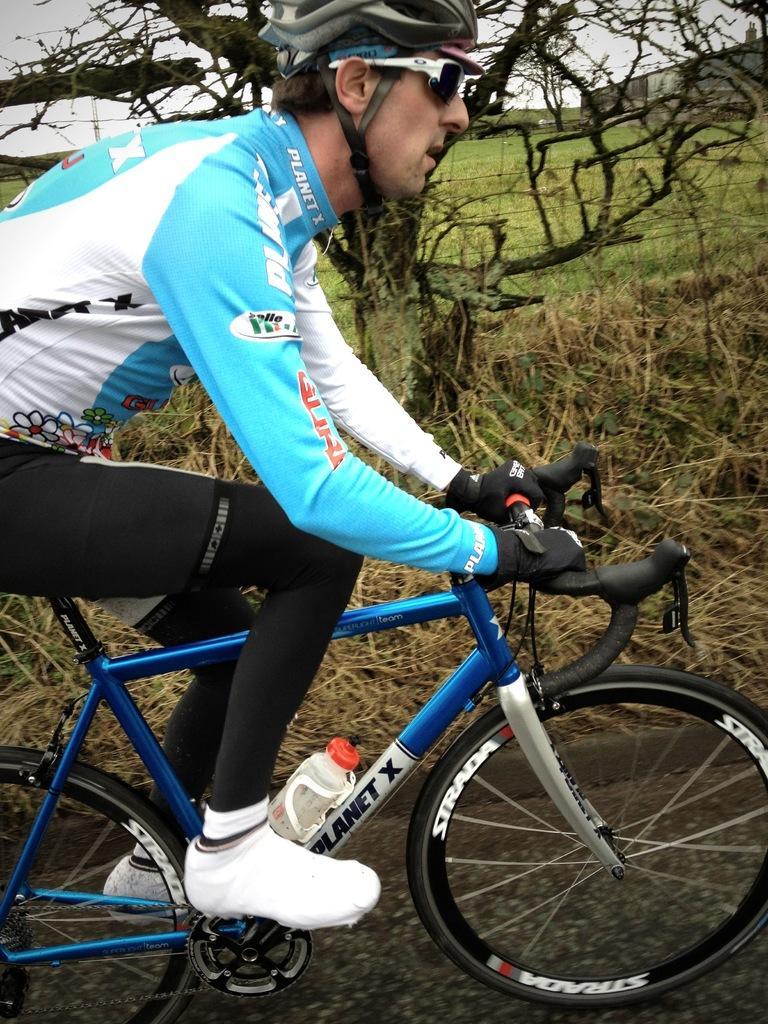Could you give a brief overview of what you see in this image? In this image we can see a man riding bicycle on the road. On the backside we can see some grass, a tree and the sky which looks cloudy. 